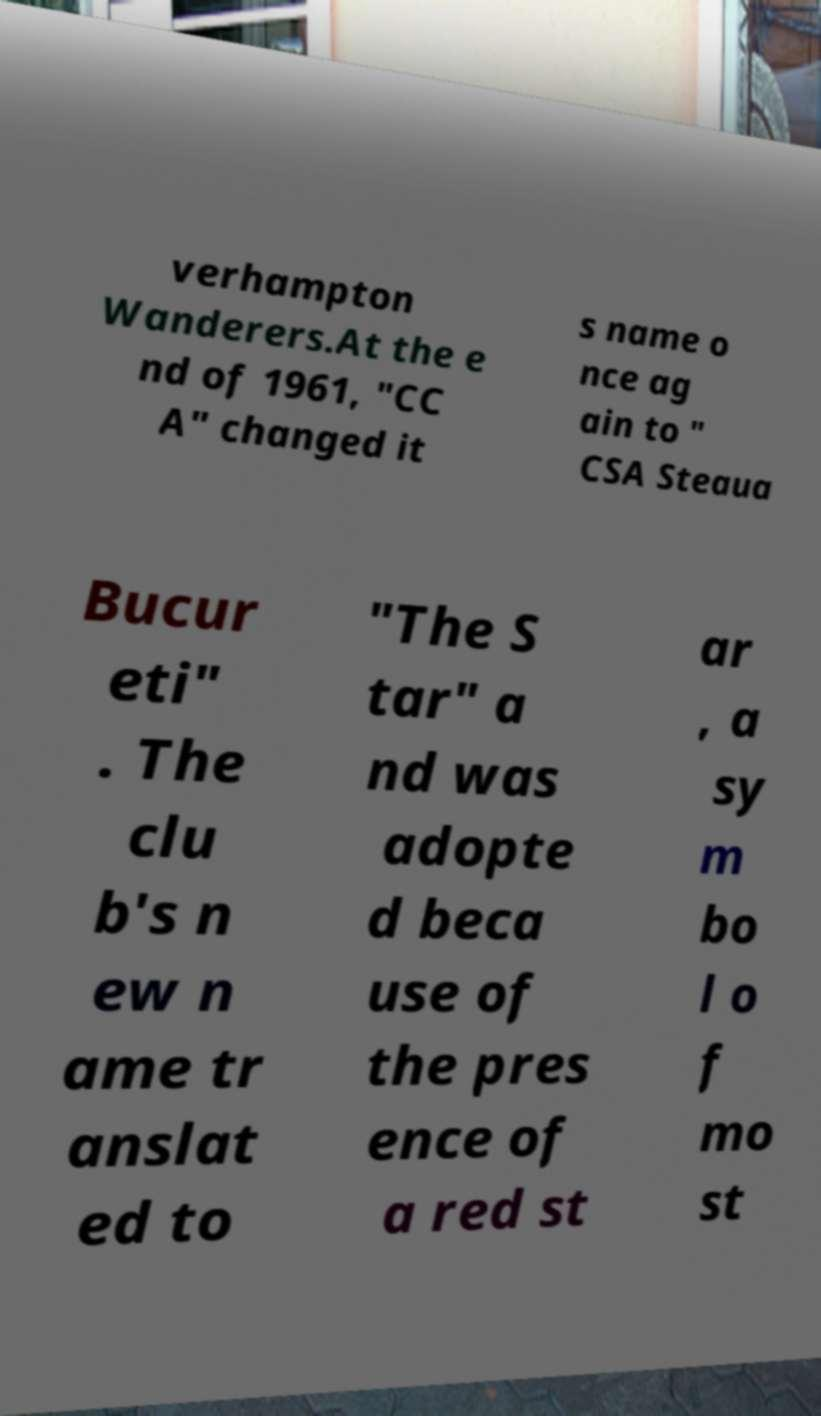Please read and relay the text visible in this image. What does it say? verhampton Wanderers.At the e nd of 1961, "CC A" changed it s name o nce ag ain to " CSA Steaua Bucur eti" . The clu b's n ew n ame tr anslat ed to "The S tar" a nd was adopte d beca use of the pres ence of a red st ar , a sy m bo l o f mo st 